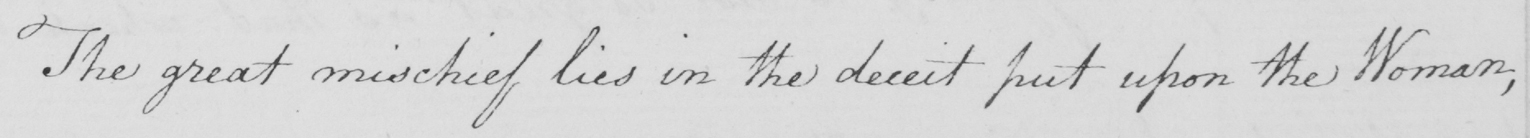Please provide the text content of this handwritten line. The great mischief lies in the deceit put upon the Woman , 